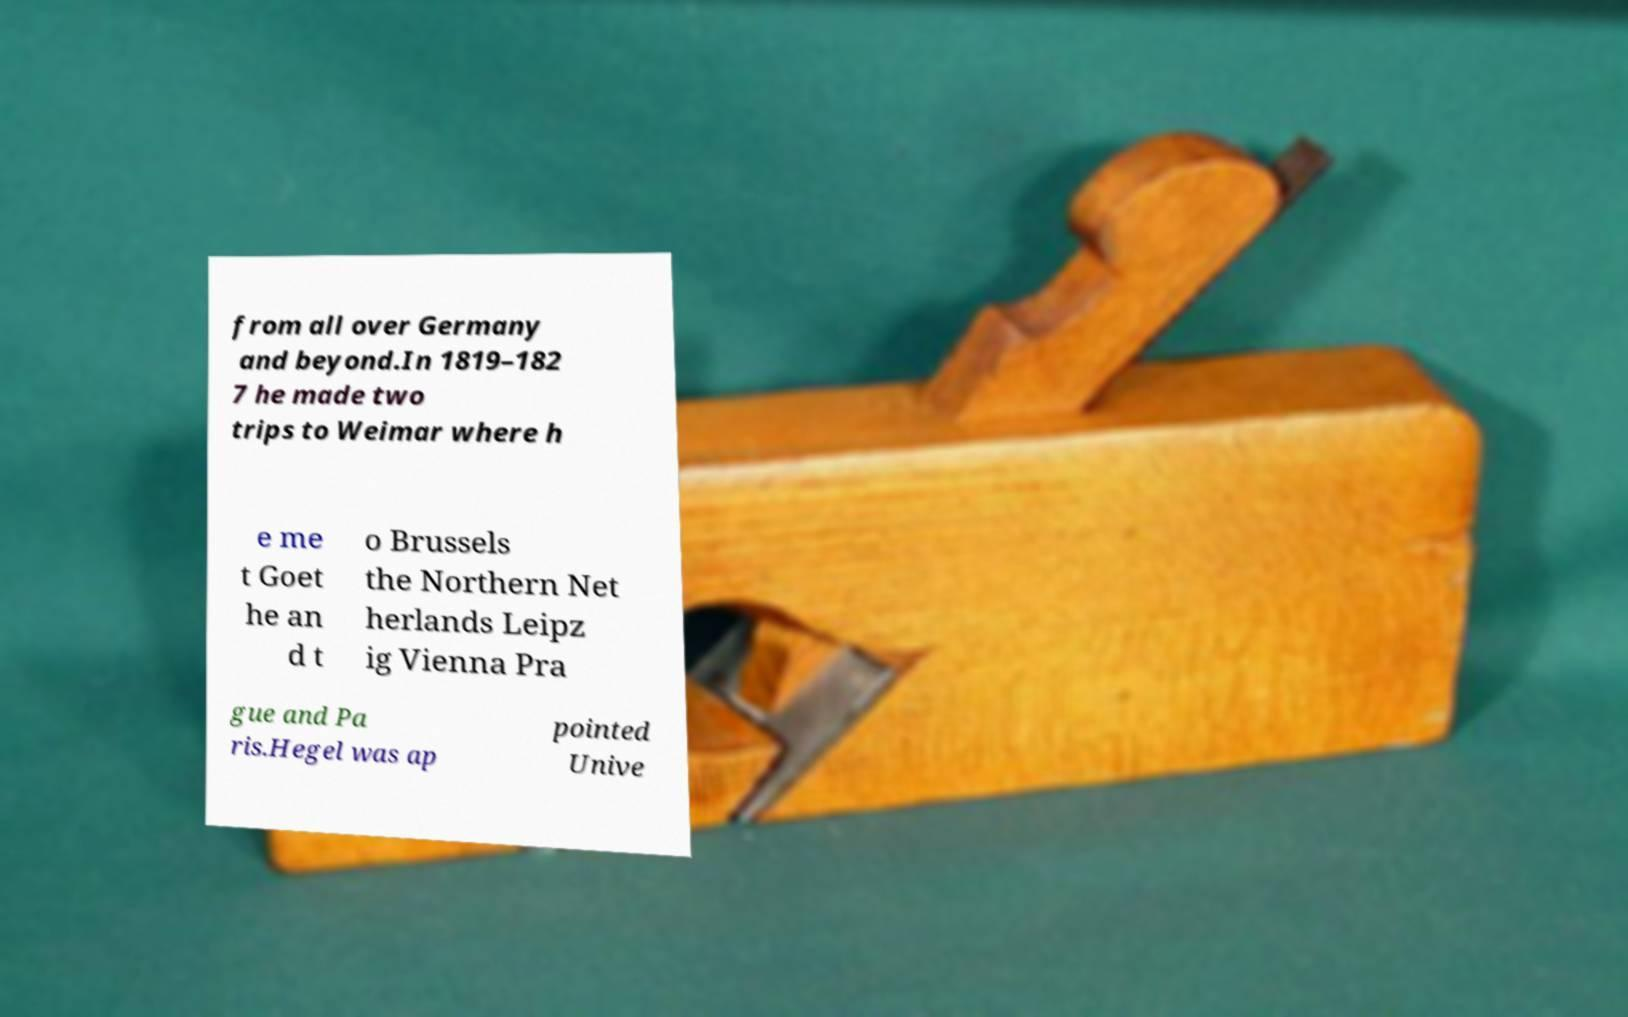Could you assist in decoding the text presented in this image and type it out clearly? from all over Germany and beyond.In 1819–182 7 he made two trips to Weimar where h e me t Goet he an d t o Brussels the Northern Net herlands Leipz ig Vienna Pra gue and Pa ris.Hegel was ap pointed Unive 